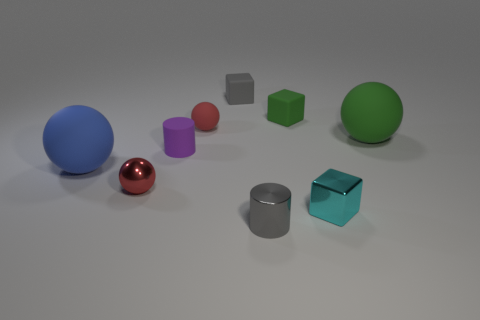How big is the ball that is in front of the small red rubber ball and behind the small purple matte object?
Your answer should be compact. Large. How many other objects are the same shape as the small purple matte thing?
Offer a terse response. 1. Is the shape of the tiny gray matte object the same as the small green matte object right of the tiny red shiny object?
Keep it short and to the point. Yes. How many green matte things are to the right of the gray cube?
Offer a terse response. 2. Is the shape of the large object in front of the green sphere the same as  the big green object?
Offer a very short reply. Yes. There is a large ball to the left of the gray metal cylinder; what is its color?
Give a very brief answer. Blue. There is a blue object that is made of the same material as the tiny gray cube; what shape is it?
Your response must be concise. Sphere. Is there anything else of the same color as the small matte cylinder?
Offer a terse response. No. Is the number of small red balls to the left of the small purple cylinder greater than the number of tiny purple matte cylinders right of the gray cube?
Ensure brevity in your answer.  Yes. What number of other cylinders are the same size as the gray shiny cylinder?
Offer a very short reply. 1. 